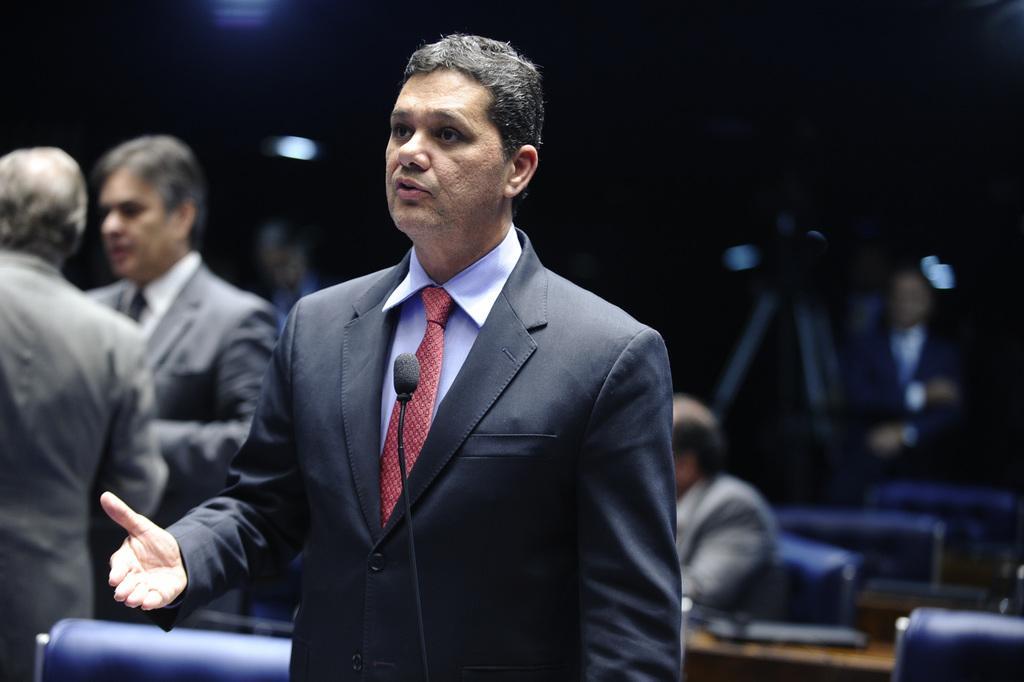Describe this image in one or two sentences. In this image there is a person standing and talking, there is a mini microphone, there is a wire truncated towards the bottom of the image, there is a person truncated towards the left of the image, there is a person sitting on a chair, there is an object on the desk, the background of the image is dark. 